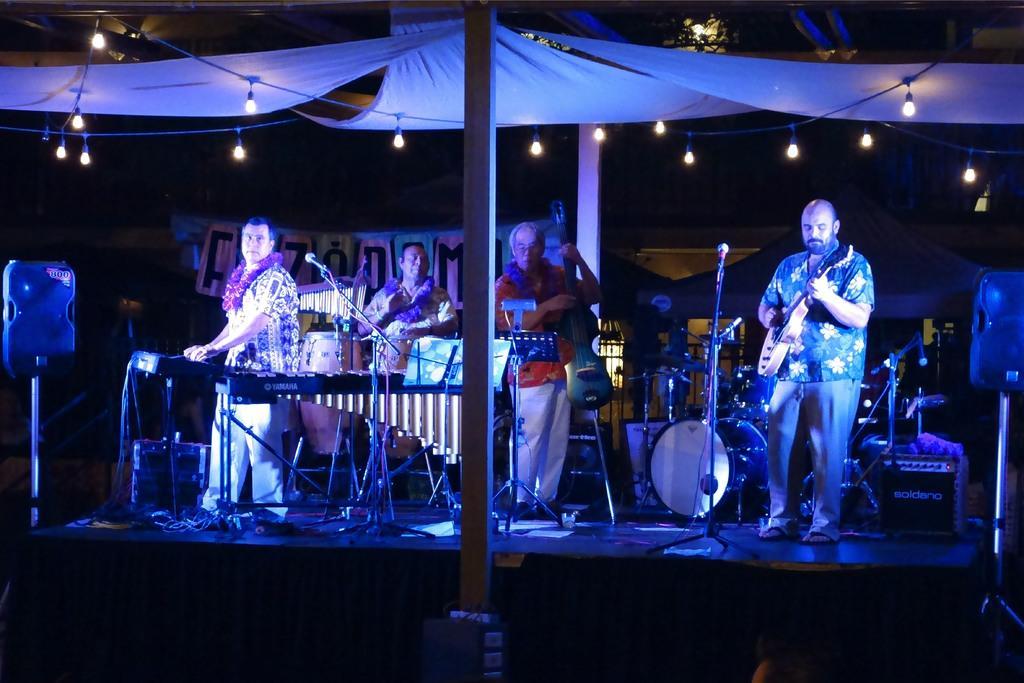How would you summarize this image in a sentence or two? In this picture we can see some persons are standing on the floor. He is playing guitar and this is mike. Here we can see some musical instruments. This is pole and these are the lights. 